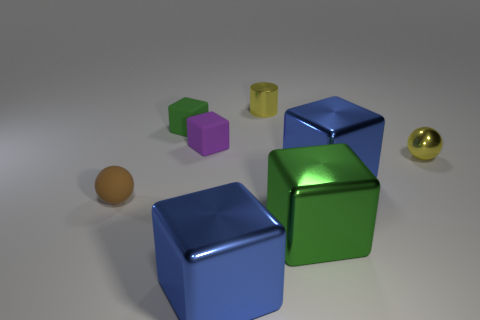Are there any blue things made of the same material as the tiny yellow cylinder?
Offer a very short reply. Yes. Are there any small purple rubber blocks on the left side of the green thing that is to the left of the metal cube on the left side of the green shiny thing?
Ensure brevity in your answer.  No. What shape is the yellow object that is the same size as the yellow shiny sphere?
Keep it short and to the point. Cylinder. Do the green cube behind the tiny purple object and the green object in front of the purple cube have the same size?
Offer a very short reply. No. What number of small yellow blocks are there?
Your answer should be very brief. 0. How big is the blue metal thing that is to the right of the blue metal block that is on the left side of the small metal object that is behind the green rubber block?
Your answer should be very brief. Large. Do the metal sphere and the small cylinder have the same color?
Provide a short and direct response. Yes. How many small green matte cubes are in front of the green metallic block?
Keep it short and to the point. 0. Are there the same number of matte things that are behind the brown rubber ball and big blue metal objects?
Make the answer very short. Yes. How many things are either green matte objects or blue things?
Provide a succinct answer. 3. 